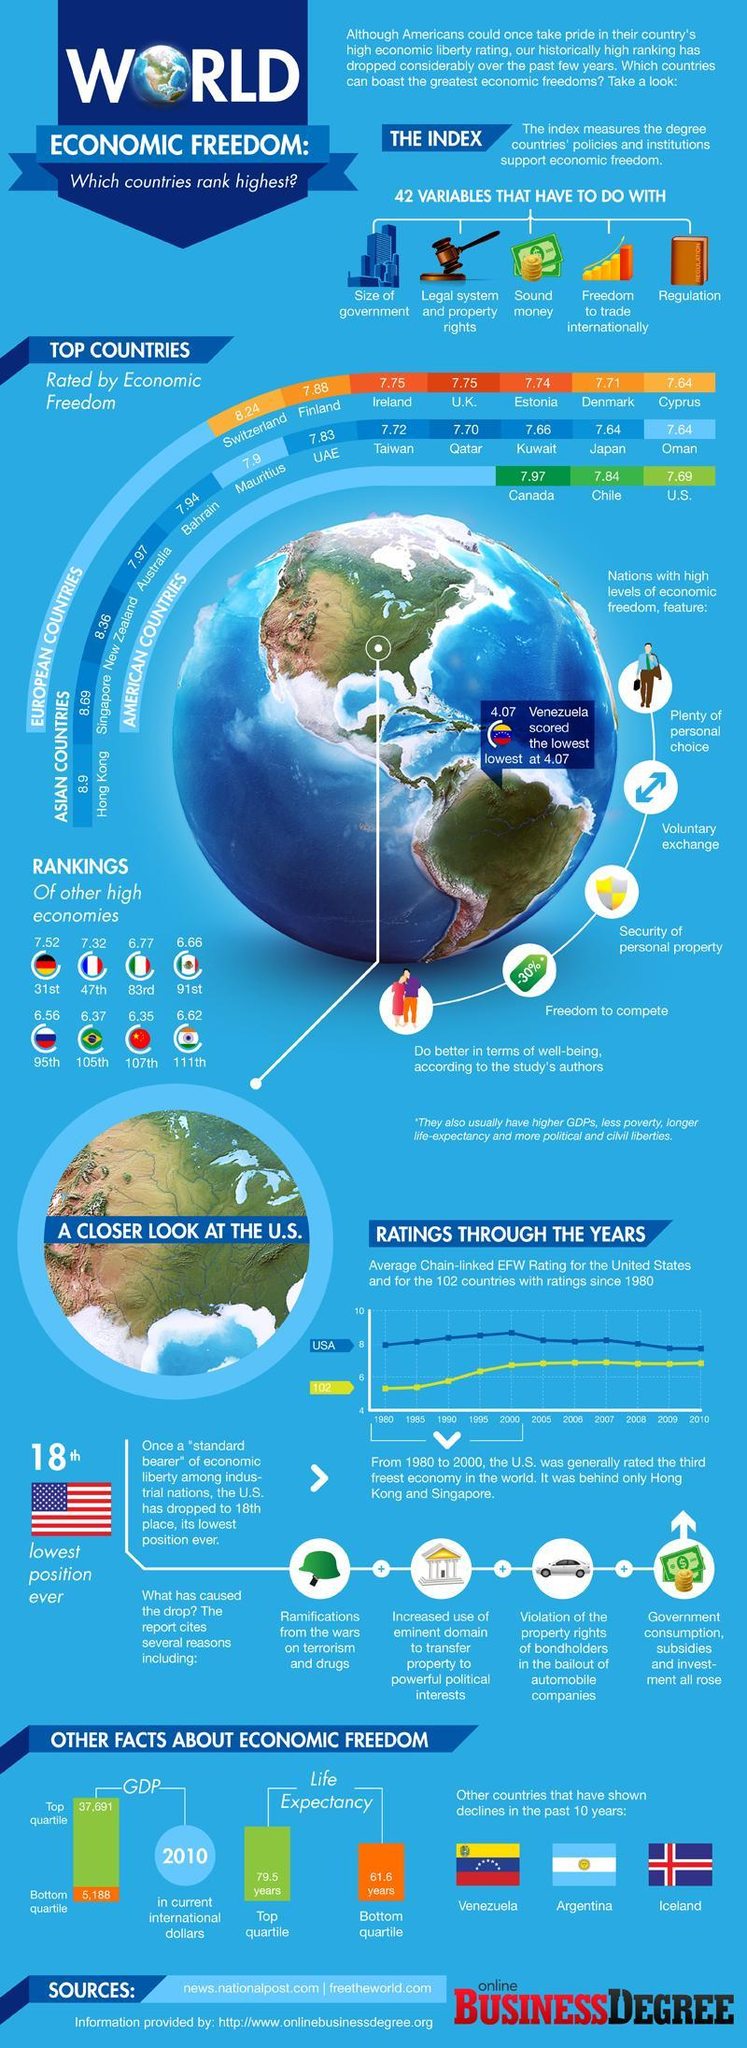Which are the countries that had a drop in economic freedom apart from the U.S.?
Answer the question with a short phrase. Venezuela, Argentina, Iceland How many countries faced a drop in economic freedom apart from the U.S.? 3 What is the rate of economic freedom of the country India? 6.62 What is the fourth advantage listed for countries with high economic freedom? Freedom to compete Which American country has the second-highest rate of economic freedom? Chile What is the second advantage listed for countries with high economic freedom? Voluntary exchange What is the Life Expectancy rate of Americans for the bottom quartile? 61.6 years Which Asian country has the fifth-highest rate of economic freedom? Bahrain Which European country has the second-highest economic freedom? Finland Which European country has the second-least economic freedom? Denmark 